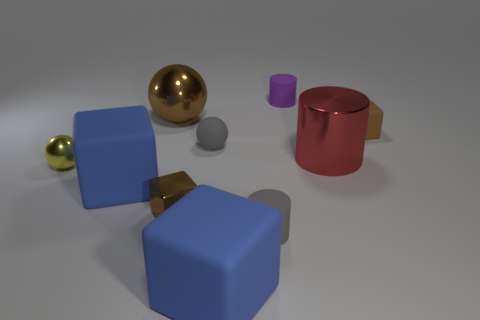Subtract 1 blocks. How many blocks are left? 3 Subtract all red cubes. Subtract all yellow spheres. How many cubes are left? 4 Subtract all blocks. How many objects are left? 6 Add 4 matte objects. How many matte objects exist? 10 Subtract 0 red cubes. How many objects are left? 10 Subtract all tiny brown matte blocks. Subtract all tiny brown things. How many objects are left? 7 Add 7 tiny brown blocks. How many tiny brown blocks are left? 9 